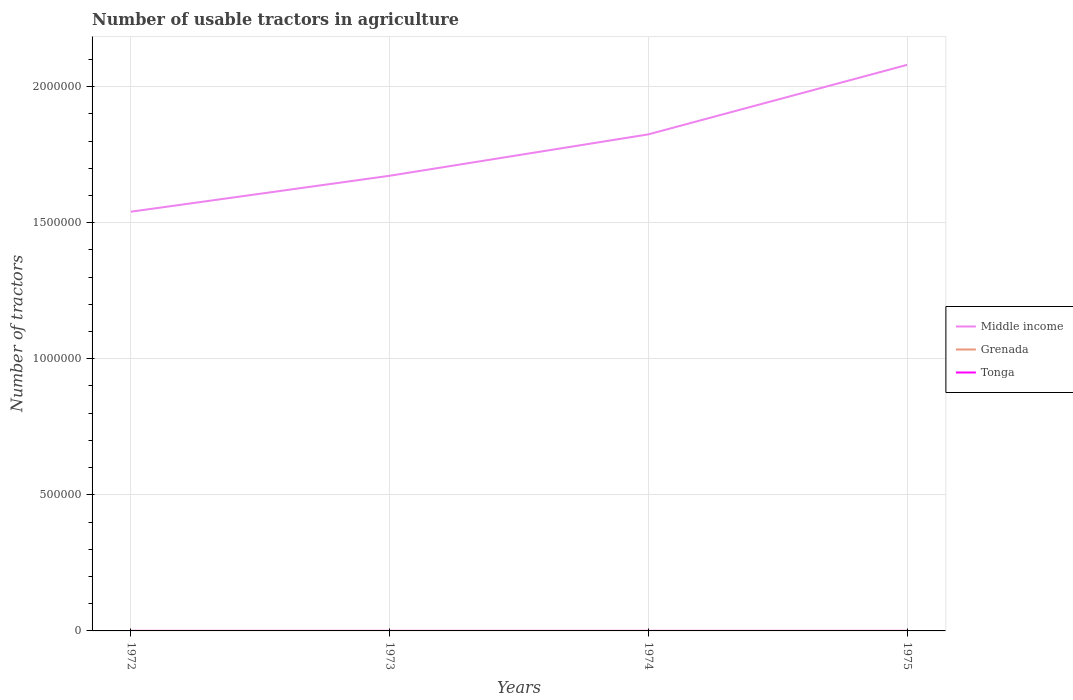In which year was the number of usable tractors in agriculture in Grenada maximum?
Provide a succinct answer. 1972. What is the total number of usable tractors in agriculture in Middle income in the graph?
Your answer should be very brief. -2.55e+05. What is the difference between the highest and the second highest number of usable tractors in agriculture in Middle income?
Offer a very short reply. 5.39e+05. How many years are there in the graph?
Offer a terse response. 4. Are the values on the major ticks of Y-axis written in scientific E-notation?
Keep it short and to the point. No. Does the graph contain any zero values?
Provide a short and direct response. No. Does the graph contain grids?
Keep it short and to the point. Yes. How are the legend labels stacked?
Your answer should be very brief. Vertical. What is the title of the graph?
Provide a short and direct response. Number of usable tractors in agriculture. What is the label or title of the Y-axis?
Keep it short and to the point. Number of tractors. What is the Number of tractors in Middle income in 1972?
Your response must be concise. 1.54e+06. What is the Number of tractors in Grenada in 1972?
Ensure brevity in your answer.  22. What is the Number of tractors of Tonga in 1972?
Provide a succinct answer. 105. What is the Number of tractors in Middle income in 1973?
Provide a succinct answer. 1.67e+06. What is the Number of tractors of Grenada in 1973?
Your response must be concise. 22. What is the Number of tractors in Tonga in 1973?
Keep it short and to the point. 105. What is the Number of tractors in Middle income in 1974?
Your answer should be compact. 1.82e+06. What is the Number of tractors of Tonga in 1974?
Your answer should be compact. 110. What is the Number of tractors of Middle income in 1975?
Ensure brevity in your answer.  2.08e+06. What is the Number of tractors of Grenada in 1975?
Make the answer very short. 22. What is the Number of tractors in Tonga in 1975?
Your answer should be very brief. 110. Across all years, what is the maximum Number of tractors of Middle income?
Your response must be concise. 2.08e+06. Across all years, what is the maximum Number of tractors in Tonga?
Offer a very short reply. 110. Across all years, what is the minimum Number of tractors of Middle income?
Offer a very short reply. 1.54e+06. Across all years, what is the minimum Number of tractors of Grenada?
Provide a succinct answer. 22. Across all years, what is the minimum Number of tractors of Tonga?
Provide a succinct answer. 105. What is the total Number of tractors in Middle income in the graph?
Your answer should be very brief. 7.12e+06. What is the total Number of tractors in Tonga in the graph?
Your answer should be compact. 430. What is the difference between the Number of tractors of Middle income in 1972 and that in 1973?
Offer a very short reply. -1.32e+05. What is the difference between the Number of tractors of Tonga in 1972 and that in 1973?
Offer a terse response. 0. What is the difference between the Number of tractors of Middle income in 1972 and that in 1974?
Your answer should be very brief. -2.84e+05. What is the difference between the Number of tractors of Tonga in 1972 and that in 1974?
Make the answer very short. -5. What is the difference between the Number of tractors in Middle income in 1972 and that in 1975?
Provide a succinct answer. -5.39e+05. What is the difference between the Number of tractors of Grenada in 1972 and that in 1975?
Offer a very short reply. 0. What is the difference between the Number of tractors of Middle income in 1973 and that in 1974?
Give a very brief answer. -1.52e+05. What is the difference between the Number of tractors in Grenada in 1973 and that in 1974?
Your response must be concise. 0. What is the difference between the Number of tractors in Tonga in 1973 and that in 1974?
Offer a very short reply. -5. What is the difference between the Number of tractors of Middle income in 1973 and that in 1975?
Your answer should be very brief. -4.07e+05. What is the difference between the Number of tractors of Middle income in 1974 and that in 1975?
Keep it short and to the point. -2.55e+05. What is the difference between the Number of tractors in Grenada in 1974 and that in 1975?
Make the answer very short. 0. What is the difference between the Number of tractors in Tonga in 1974 and that in 1975?
Ensure brevity in your answer.  0. What is the difference between the Number of tractors in Middle income in 1972 and the Number of tractors in Grenada in 1973?
Keep it short and to the point. 1.54e+06. What is the difference between the Number of tractors in Middle income in 1972 and the Number of tractors in Tonga in 1973?
Offer a terse response. 1.54e+06. What is the difference between the Number of tractors in Grenada in 1972 and the Number of tractors in Tonga in 1973?
Give a very brief answer. -83. What is the difference between the Number of tractors in Middle income in 1972 and the Number of tractors in Grenada in 1974?
Your response must be concise. 1.54e+06. What is the difference between the Number of tractors in Middle income in 1972 and the Number of tractors in Tonga in 1974?
Make the answer very short. 1.54e+06. What is the difference between the Number of tractors in Grenada in 1972 and the Number of tractors in Tonga in 1974?
Offer a terse response. -88. What is the difference between the Number of tractors of Middle income in 1972 and the Number of tractors of Grenada in 1975?
Offer a very short reply. 1.54e+06. What is the difference between the Number of tractors in Middle income in 1972 and the Number of tractors in Tonga in 1975?
Provide a short and direct response. 1.54e+06. What is the difference between the Number of tractors in Grenada in 1972 and the Number of tractors in Tonga in 1975?
Your answer should be very brief. -88. What is the difference between the Number of tractors in Middle income in 1973 and the Number of tractors in Grenada in 1974?
Offer a terse response. 1.67e+06. What is the difference between the Number of tractors of Middle income in 1973 and the Number of tractors of Tonga in 1974?
Keep it short and to the point. 1.67e+06. What is the difference between the Number of tractors of Grenada in 1973 and the Number of tractors of Tonga in 1974?
Your answer should be very brief. -88. What is the difference between the Number of tractors in Middle income in 1973 and the Number of tractors in Grenada in 1975?
Give a very brief answer. 1.67e+06. What is the difference between the Number of tractors of Middle income in 1973 and the Number of tractors of Tonga in 1975?
Your response must be concise. 1.67e+06. What is the difference between the Number of tractors of Grenada in 1973 and the Number of tractors of Tonga in 1975?
Make the answer very short. -88. What is the difference between the Number of tractors of Middle income in 1974 and the Number of tractors of Grenada in 1975?
Offer a terse response. 1.82e+06. What is the difference between the Number of tractors in Middle income in 1974 and the Number of tractors in Tonga in 1975?
Make the answer very short. 1.82e+06. What is the difference between the Number of tractors in Grenada in 1974 and the Number of tractors in Tonga in 1975?
Your answer should be compact. -88. What is the average Number of tractors in Middle income per year?
Provide a succinct answer. 1.78e+06. What is the average Number of tractors of Tonga per year?
Make the answer very short. 107.5. In the year 1972, what is the difference between the Number of tractors in Middle income and Number of tractors in Grenada?
Provide a succinct answer. 1.54e+06. In the year 1972, what is the difference between the Number of tractors in Middle income and Number of tractors in Tonga?
Offer a terse response. 1.54e+06. In the year 1972, what is the difference between the Number of tractors in Grenada and Number of tractors in Tonga?
Your answer should be compact. -83. In the year 1973, what is the difference between the Number of tractors in Middle income and Number of tractors in Grenada?
Provide a succinct answer. 1.67e+06. In the year 1973, what is the difference between the Number of tractors in Middle income and Number of tractors in Tonga?
Offer a very short reply. 1.67e+06. In the year 1973, what is the difference between the Number of tractors of Grenada and Number of tractors of Tonga?
Offer a terse response. -83. In the year 1974, what is the difference between the Number of tractors in Middle income and Number of tractors in Grenada?
Keep it short and to the point. 1.82e+06. In the year 1974, what is the difference between the Number of tractors of Middle income and Number of tractors of Tonga?
Your answer should be compact. 1.82e+06. In the year 1974, what is the difference between the Number of tractors in Grenada and Number of tractors in Tonga?
Your response must be concise. -88. In the year 1975, what is the difference between the Number of tractors in Middle income and Number of tractors in Grenada?
Provide a short and direct response. 2.08e+06. In the year 1975, what is the difference between the Number of tractors in Middle income and Number of tractors in Tonga?
Ensure brevity in your answer.  2.08e+06. In the year 1975, what is the difference between the Number of tractors in Grenada and Number of tractors in Tonga?
Keep it short and to the point. -88. What is the ratio of the Number of tractors in Middle income in 1972 to that in 1973?
Your answer should be very brief. 0.92. What is the ratio of the Number of tractors of Grenada in 1972 to that in 1973?
Make the answer very short. 1. What is the ratio of the Number of tractors of Tonga in 1972 to that in 1973?
Provide a short and direct response. 1. What is the ratio of the Number of tractors in Middle income in 1972 to that in 1974?
Your answer should be very brief. 0.84. What is the ratio of the Number of tractors of Tonga in 1972 to that in 1974?
Ensure brevity in your answer.  0.95. What is the ratio of the Number of tractors of Middle income in 1972 to that in 1975?
Provide a succinct answer. 0.74. What is the ratio of the Number of tractors in Tonga in 1972 to that in 1975?
Your response must be concise. 0.95. What is the ratio of the Number of tractors in Middle income in 1973 to that in 1974?
Give a very brief answer. 0.92. What is the ratio of the Number of tractors in Grenada in 1973 to that in 1974?
Your answer should be compact. 1. What is the ratio of the Number of tractors in Tonga in 1973 to that in 1974?
Keep it short and to the point. 0.95. What is the ratio of the Number of tractors in Middle income in 1973 to that in 1975?
Offer a very short reply. 0.8. What is the ratio of the Number of tractors of Tonga in 1973 to that in 1975?
Offer a terse response. 0.95. What is the ratio of the Number of tractors of Middle income in 1974 to that in 1975?
Provide a short and direct response. 0.88. What is the difference between the highest and the second highest Number of tractors in Middle income?
Provide a succinct answer. 2.55e+05. What is the difference between the highest and the lowest Number of tractors in Middle income?
Make the answer very short. 5.39e+05. What is the difference between the highest and the lowest Number of tractors of Tonga?
Ensure brevity in your answer.  5. 